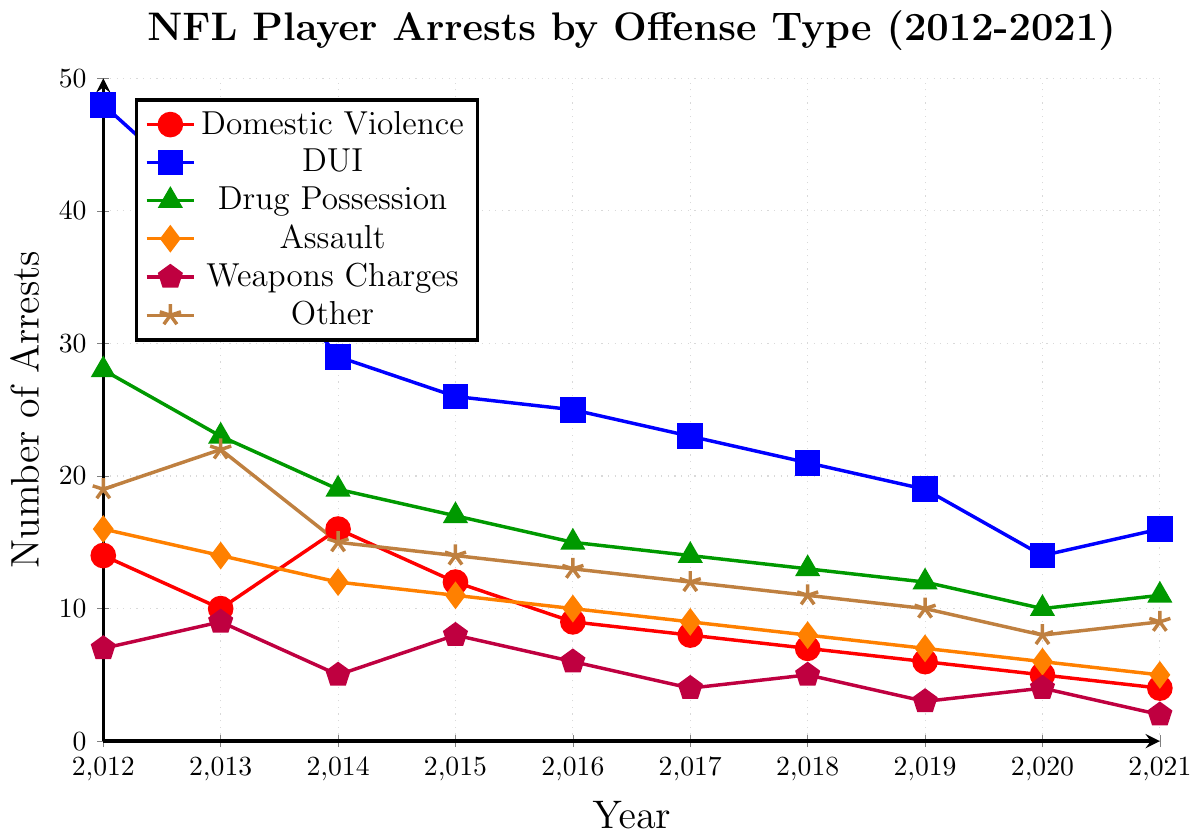Which type of offense has the highest number of arrests in 2012? By observing the peaks in the lines for the year 2012, the line representing DUI (blue line with square markers) is the highest.
Answer: DUI Which offense type shows a consistent decrease in the number of arrests from 2012 to 2021? By visually inspecting the trends in the lines, DUI (blue line with square markers) shows a consistent downward trend.
Answer: DUI How many arrests occurred due to Drug Possession in 2014 and in 2019? What is the difference? Look at the green line with triangle markers for the years 2014 and 2019. In 2014, there are 19 arrests, and in 2019, there are 12 arrests. The difference is 19 - 12.
Answer: 7 Which offense type had the least number of arrests in 2021? By observing the endpoints for the year 2021, the purple line with pentagon markers (Weapons Charges) ends at the lowest point.
Answer: Weapons Charges Which two offense types have the closest number of arrests in 2015? What are their values? In 2015, the lines for Assault (orange line with diamond markers) and Weapons Charges (purple line with pentagon markers) are closest. Assault has 11 arrests and Weapons Charges have 8 arrests, the difference is small.
Answer: Assault - 11, Weapons Charges - 8 What is the total number of arrests for Domestic Violence over the entire period? Sum the values of the red line with circle markers from 2012 to 2021: 14 + 10 + 16 + 12 + 9 + 8 + 7 + 6 + 5 + 4 = 91.
Answer: 91 Among all offense types, which had the sharpest decrease in arrests from 2012 to 2020? Observing the slopes of the lines, DUI (blue line with square markers) decreases sharply from 48 in 2012 to 14 in 2020, a decline of 34 arrests.
Answer: DUI Did any offense type have the exact same number of arrests in two different years? If yes, which offense type and years? By closely observing each line, DUI (blue line with square markers) had 16 arrests in both 2013 and 2021.
Answer: DUI, 2013 and 2021 What is the average number of arrests per year for Assault from 2012 to 2021? The values are 16, 14, 12, 11, 10, 9, 8, 7, 6, 5. Sum these values to get 98 and then divide by 10 (number of years). 98/10 = 9.8.
Answer: 9.8 